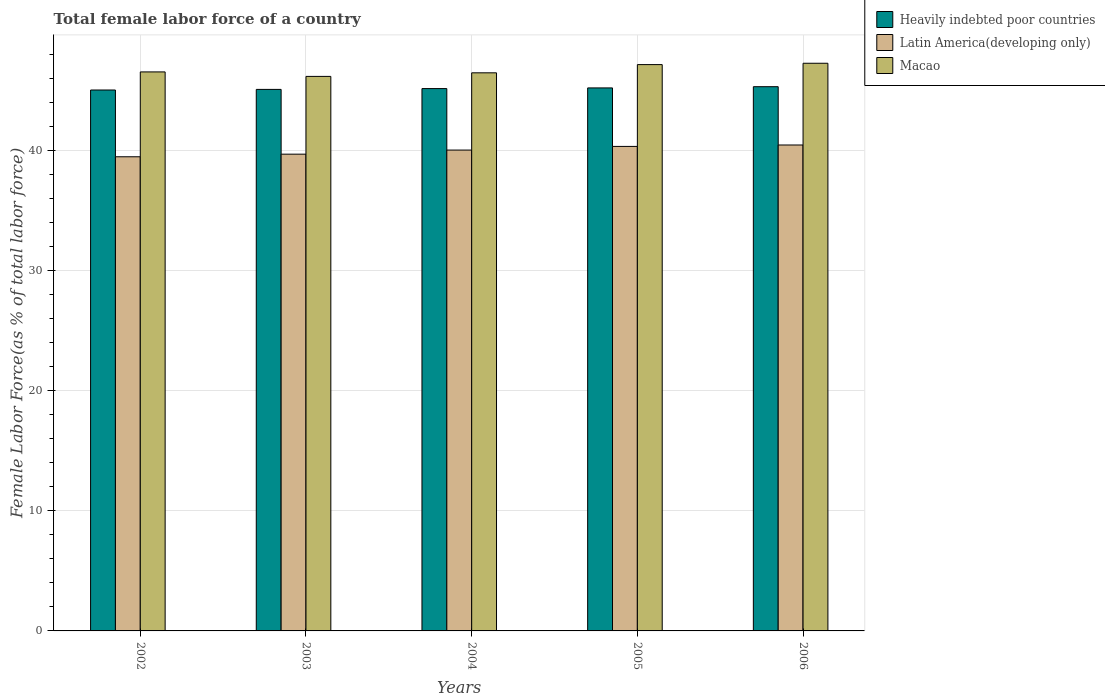How many groups of bars are there?
Give a very brief answer. 5. Are the number of bars per tick equal to the number of legend labels?
Make the answer very short. Yes. How many bars are there on the 1st tick from the right?
Keep it short and to the point. 3. What is the percentage of female labor force in Heavily indebted poor countries in 2004?
Your answer should be compact. 45.15. Across all years, what is the maximum percentage of female labor force in Latin America(developing only)?
Make the answer very short. 40.45. Across all years, what is the minimum percentage of female labor force in Latin America(developing only)?
Offer a terse response. 39.47. What is the total percentage of female labor force in Latin America(developing only) in the graph?
Your response must be concise. 199.96. What is the difference between the percentage of female labor force in Heavily indebted poor countries in 2004 and that in 2005?
Ensure brevity in your answer.  -0.06. What is the difference between the percentage of female labor force in Macao in 2003 and the percentage of female labor force in Heavily indebted poor countries in 2006?
Ensure brevity in your answer.  0.86. What is the average percentage of female labor force in Latin America(developing only) per year?
Make the answer very short. 39.99. In the year 2005, what is the difference between the percentage of female labor force in Macao and percentage of female labor force in Latin America(developing only)?
Ensure brevity in your answer.  6.81. What is the ratio of the percentage of female labor force in Heavily indebted poor countries in 2002 to that in 2005?
Your response must be concise. 1. Is the percentage of female labor force in Macao in 2003 less than that in 2005?
Make the answer very short. Yes. What is the difference between the highest and the second highest percentage of female labor force in Heavily indebted poor countries?
Provide a succinct answer. 0.1. What is the difference between the highest and the lowest percentage of female labor force in Latin America(developing only)?
Ensure brevity in your answer.  0.98. Is the sum of the percentage of female labor force in Macao in 2003 and 2006 greater than the maximum percentage of female labor force in Heavily indebted poor countries across all years?
Give a very brief answer. Yes. What does the 1st bar from the left in 2003 represents?
Offer a terse response. Heavily indebted poor countries. What does the 1st bar from the right in 2004 represents?
Your response must be concise. Macao. Is it the case that in every year, the sum of the percentage of female labor force in Macao and percentage of female labor force in Heavily indebted poor countries is greater than the percentage of female labor force in Latin America(developing only)?
Give a very brief answer. Yes. How many years are there in the graph?
Ensure brevity in your answer.  5. Are the values on the major ticks of Y-axis written in scientific E-notation?
Ensure brevity in your answer.  No. Does the graph contain any zero values?
Give a very brief answer. No. Does the graph contain grids?
Offer a terse response. Yes. How are the legend labels stacked?
Offer a terse response. Vertical. What is the title of the graph?
Ensure brevity in your answer.  Total female labor force of a country. Does "Sierra Leone" appear as one of the legend labels in the graph?
Give a very brief answer. No. What is the label or title of the Y-axis?
Offer a terse response. Female Labor Force(as % of total labor force). What is the Female Labor Force(as % of total labor force) in Heavily indebted poor countries in 2002?
Give a very brief answer. 45.03. What is the Female Labor Force(as % of total labor force) of Latin America(developing only) in 2002?
Offer a very short reply. 39.47. What is the Female Labor Force(as % of total labor force) of Macao in 2002?
Your answer should be compact. 46.53. What is the Female Labor Force(as % of total labor force) in Heavily indebted poor countries in 2003?
Provide a short and direct response. 45.08. What is the Female Labor Force(as % of total labor force) of Latin America(developing only) in 2003?
Offer a very short reply. 39.69. What is the Female Labor Force(as % of total labor force) in Macao in 2003?
Your response must be concise. 46.16. What is the Female Labor Force(as % of total labor force) of Heavily indebted poor countries in 2004?
Keep it short and to the point. 45.15. What is the Female Labor Force(as % of total labor force) of Latin America(developing only) in 2004?
Provide a short and direct response. 40.03. What is the Female Labor Force(as % of total labor force) of Macao in 2004?
Offer a very short reply. 46.46. What is the Female Labor Force(as % of total labor force) in Heavily indebted poor countries in 2005?
Provide a succinct answer. 45.2. What is the Female Labor Force(as % of total labor force) of Latin America(developing only) in 2005?
Your response must be concise. 40.33. What is the Female Labor Force(as % of total labor force) in Macao in 2005?
Ensure brevity in your answer.  47.14. What is the Female Labor Force(as % of total labor force) of Heavily indebted poor countries in 2006?
Your answer should be compact. 45.3. What is the Female Labor Force(as % of total labor force) in Latin America(developing only) in 2006?
Ensure brevity in your answer.  40.45. What is the Female Labor Force(as % of total labor force) in Macao in 2006?
Provide a succinct answer. 47.25. Across all years, what is the maximum Female Labor Force(as % of total labor force) in Heavily indebted poor countries?
Your answer should be compact. 45.3. Across all years, what is the maximum Female Labor Force(as % of total labor force) in Latin America(developing only)?
Offer a terse response. 40.45. Across all years, what is the maximum Female Labor Force(as % of total labor force) of Macao?
Give a very brief answer. 47.25. Across all years, what is the minimum Female Labor Force(as % of total labor force) of Heavily indebted poor countries?
Provide a succinct answer. 45.03. Across all years, what is the minimum Female Labor Force(as % of total labor force) in Latin America(developing only)?
Ensure brevity in your answer.  39.47. Across all years, what is the minimum Female Labor Force(as % of total labor force) of Macao?
Offer a very short reply. 46.16. What is the total Female Labor Force(as % of total labor force) in Heavily indebted poor countries in the graph?
Make the answer very short. 225.75. What is the total Female Labor Force(as % of total labor force) in Latin America(developing only) in the graph?
Make the answer very short. 199.96. What is the total Female Labor Force(as % of total labor force) in Macao in the graph?
Provide a succinct answer. 233.54. What is the difference between the Female Labor Force(as % of total labor force) of Heavily indebted poor countries in 2002 and that in 2003?
Your answer should be very brief. -0.05. What is the difference between the Female Labor Force(as % of total labor force) of Latin America(developing only) in 2002 and that in 2003?
Provide a succinct answer. -0.22. What is the difference between the Female Labor Force(as % of total labor force) of Macao in 2002 and that in 2003?
Your answer should be very brief. 0.37. What is the difference between the Female Labor Force(as % of total labor force) of Heavily indebted poor countries in 2002 and that in 2004?
Keep it short and to the point. -0.12. What is the difference between the Female Labor Force(as % of total labor force) in Latin America(developing only) in 2002 and that in 2004?
Ensure brevity in your answer.  -0.56. What is the difference between the Female Labor Force(as % of total labor force) of Macao in 2002 and that in 2004?
Your answer should be compact. 0.08. What is the difference between the Female Labor Force(as % of total labor force) in Heavily indebted poor countries in 2002 and that in 2005?
Your answer should be very brief. -0.17. What is the difference between the Female Labor Force(as % of total labor force) of Latin America(developing only) in 2002 and that in 2005?
Make the answer very short. -0.86. What is the difference between the Female Labor Force(as % of total labor force) of Macao in 2002 and that in 2005?
Your response must be concise. -0.61. What is the difference between the Female Labor Force(as % of total labor force) in Heavily indebted poor countries in 2002 and that in 2006?
Your answer should be compact. -0.28. What is the difference between the Female Labor Force(as % of total labor force) in Latin America(developing only) in 2002 and that in 2006?
Your answer should be very brief. -0.98. What is the difference between the Female Labor Force(as % of total labor force) of Macao in 2002 and that in 2006?
Your response must be concise. -0.72. What is the difference between the Female Labor Force(as % of total labor force) in Heavily indebted poor countries in 2003 and that in 2004?
Give a very brief answer. -0.07. What is the difference between the Female Labor Force(as % of total labor force) in Latin America(developing only) in 2003 and that in 2004?
Your answer should be very brief. -0.34. What is the difference between the Female Labor Force(as % of total labor force) in Macao in 2003 and that in 2004?
Offer a terse response. -0.3. What is the difference between the Female Labor Force(as % of total labor force) in Heavily indebted poor countries in 2003 and that in 2005?
Your response must be concise. -0.12. What is the difference between the Female Labor Force(as % of total labor force) in Latin America(developing only) in 2003 and that in 2005?
Ensure brevity in your answer.  -0.65. What is the difference between the Female Labor Force(as % of total labor force) in Macao in 2003 and that in 2005?
Your answer should be compact. -0.98. What is the difference between the Female Labor Force(as % of total labor force) in Heavily indebted poor countries in 2003 and that in 2006?
Provide a short and direct response. -0.22. What is the difference between the Female Labor Force(as % of total labor force) of Latin America(developing only) in 2003 and that in 2006?
Your response must be concise. -0.76. What is the difference between the Female Labor Force(as % of total labor force) in Macao in 2003 and that in 2006?
Offer a terse response. -1.09. What is the difference between the Female Labor Force(as % of total labor force) in Heavily indebted poor countries in 2004 and that in 2005?
Make the answer very short. -0.06. What is the difference between the Female Labor Force(as % of total labor force) of Latin America(developing only) in 2004 and that in 2005?
Give a very brief answer. -0.3. What is the difference between the Female Labor Force(as % of total labor force) in Macao in 2004 and that in 2005?
Your response must be concise. -0.68. What is the difference between the Female Labor Force(as % of total labor force) in Heavily indebted poor countries in 2004 and that in 2006?
Offer a very short reply. -0.16. What is the difference between the Female Labor Force(as % of total labor force) of Latin America(developing only) in 2004 and that in 2006?
Offer a terse response. -0.42. What is the difference between the Female Labor Force(as % of total labor force) in Macao in 2004 and that in 2006?
Keep it short and to the point. -0.8. What is the difference between the Female Labor Force(as % of total labor force) of Heavily indebted poor countries in 2005 and that in 2006?
Make the answer very short. -0.1. What is the difference between the Female Labor Force(as % of total labor force) of Latin America(developing only) in 2005 and that in 2006?
Make the answer very short. -0.12. What is the difference between the Female Labor Force(as % of total labor force) of Macao in 2005 and that in 2006?
Make the answer very short. -0.11. What is the difference between the Female Labor Force(as % of total labor force) of Heavily indebted poor countries in 2002 and the Female Labor Force(as % of total labor force) of Latin America(developing only) in 2003?
Your answer should be compact. 5.34. What is the difference between the Female Labor Force(as % of total labor force) in Heavily indebted poor countries in 2002 and the Female Labor Force(as % of total labor force) in Macao in 2003?
Your answer should be very brief. -1.13. What is the difference between the Female Labor Force(as % of total labor force) of Latin America(developing only) in 2002 and the Female Labor Force(as % of total labor force) of Macao in 2003?
Your answer should be very brief. -6.69. What is the difference between the Female Labor Force(as % of total labor force) of Heavily indebted poor countries in 2002 and the Female Labor Force(as % of total labor force) of Latin America(developing only) in 2004?
Give a very brief answer. 5. What is the difference between the Female Labor Force(as % of total labor force) in Heavily indebted poor countries in 2002 and the Female Labor Force(as % of total labor force) in Macao in 2004?
Offer a terse response. -1.43. What is the difference between the Female Labor Force(as % of total labor force) of Latin America(developing only) in 2002 and the Female Labor Force(as % of total labor force) of Macao in 2004?
Keep it short and to the point. -6.99. What is the difference between the Female Labor Force(as % of total labor force) of Heavily indebted poor countries in 2002 and the Female Labor Force(as % of total labor force) of Latin America(developing only) in 2005?
Keep it short and to the point. 4.7. What is the difference between the Female Labor Force(as % of total labor force) of Heavily indebted poor countries in 2002 and the Female Labor Force(as % of total labor force) of Macao in 2005?
Your answer should be compact. -2.12. What is the difference between the Female Labor Force(as % of total labor force) of Latin America(developing only) in 2002 and the Female Labor Force(as % of total labor force) of Macao in 2005?
Offer a very short reply. -7.67. What is the difference between the Female Labor Force(as % of total labor force) in Heavily indebted poor countries in 2002 and the Female Labor Force(as % of total labor force) in Latin America(developing only) in 2006?
Offer a very short reply. 4.58. What is the difference between the Female Labor Force(as % of total labor force) in Heavily indebted poor countries in 2002 and the Female Labor Force(as % of total labor force) in Macao in 2006?
Provide a short and direct response. -2.23. What is the difference between the Female Labor Force(as % of total labor force) of Latin America(developing only) in 2002 and the Female Labor Force(as % of total labor force) of Macao in 2006?
Your answer should be very brief. -7.78. What is the difference between the Female Labor Force(as % of total labor force) of Heavily indebted poor countries in 2003 and the Female Labor Force(as % of total labor force) of Latin America(developing only) in 2004?
Your answer should be compact. 5.05. What is the difference between the Female Labor Force(as % of total labor force) in Heavily indebted poor countries in 2003 and the Female Labor Force(as % of total labor force) in Macao in 2004?
Your answer should be very brief. -1.38. What is the difference between the Female Labor Force(as % of total labor force) of Latin America(developing only) in 2003 and the Female Labor Force(as % of total labor force) of Macao in 2004?
Provide a short and direct response. -6.77. What is the difference between the Female Labor Force(as % of total labor force) of Heavily indebted poor countries in 2003 and the Female Labor Force(as % of total labor force) of Latin America(developing only) in 2005?
Offer a very short reply. 4.75. What is the difference between the Female Labor Force(as % of total labor force) of Heavily indebted poor countries in 2003 and the Female Labor Force(as % of total labor force) of Macao in 2005?
Offer a very short reply. -2.06. What is the difference between the Female Labor Force(as % of total labor force) of Latin America(developing only) in 2003 and the Female Labor Force(as % of total labor force) of Macao in 2005?
Your answer should be very brief. -7.46. What is the difference between the Female Labor Force(as % of total labor force) in Heavily indebted poor countries in 2003 and the Female Labor Force(as % of total labor force) in Latin America(developing only) in 2006?
Your answer should be very brief. 4.63. What is the difference between the Female Labor Force(as % of total labor force) in Heavily indebted poor countries in 2003 and the Female Labor Force(as % of total labor force) in Macao in 2006?
Give a very brief answer. -2.18. What is the difference between the Female Labor Force(as % of total labor force) in Latin America(developing only) in 2003 and the Female Labor Force(as % of total labor force) in Macao in 2006?
Provide a succinct answer. -7.57. What is the difference between the Female Labor Force(as % of total labor force) in Heavily indebted poor countries in 2004 and the Female Labor Force(as % of total labor force) in Latin America(developing only) in 2005?
Give a very brief answer. 4.81. What is the difference between the Female Labor Force(as % of total labor force) of Heavily indebted poor countries in 2004 and the Female Labor Force(as % of total labor force) of Macao in 2005?
Your answer should be very brief. -2. What is the difference between the Female Labor Force(as % of total labor force) of Latin America(developing only) in 2004 and the Female Labor Force(as % of total labor force) of Macao in 2005?
Make the answer very short. -7.11. What is the difference between the Female Labor Force(as % of total labor force) in Heavily indebted poor countries in 2004 and the Female Labor Force(as % of total labor force) in Latin America(developing only) in 2006?
Your response must be concise. 4.7. What is the difference between the Female Labor Force(as % of total labor force) in Heavily indebted poor countries in 2004 and the Female Labor Force(as % of total labor force) in Macao in 2006?
Offer a very short reply. -2.11. What is the difference between the Female Labor Force(as % of total labor force) of Latin America(developing only) in 2004 and the Female Labor Force(as % of total labor force) of Macao in 2006?
Your answer should be very brief. -7.23. What is the difference between the Female Labor Force(as % of total labor force) in Heavily indebted poor countries in 2005 and the Female Labor Force(as % of total labor force) in Latin America(developing only) in 2006?
Provide a succinct answer. 4.75. What is the difference between the Female Labor Force(as % of total labor force) in Heavily indebted poor countries in 2005 and the Female Labor Force(as % of total labor force) in Macao in 2006?
Your answer should be very brief. -2.05. What is the difference between the Female Labor Force(as % of total labor force) in Latin America(developing only) in 2005 and the Female Labor Force(as % of total labor force) in Macao in 2006?
Provide a succinct answer. -6.92. What is the average Female Labor Force(as % of total labor force) in Heavily indebted poor countries per year?
Provide a succinct answer. 45.15. What is the average Female Labor Force(as % of total labor force) in Latin America(developing only) per year?
Your answer should be very brief. 39.99. What is the average Female Labor Force(as % of total labor force) of Macao per year?
Your answer should be compact. 46.71. In the year 2002, what is the difference between the Female Labor Force(as % of total labor force) in Heavily indebted poor countries and Female Labor Force(as % of total labor force) in Latin America(developing only)?
Ensure brevity in your answer.  5.56. In the year 2002, what is the difference between the Female Labor Force(as % of total labor force) of Heavily indebted poor countries and Female Labor Force(as % of total labor force) of Macao?
Keep it short and to the point. -1.51. In the year 2002, what is the difference between the Female Labor Force(as % of total labor force) of Latin America(developing only) and Female Labor Force(as % of total labor force) of Macao?
Your answer should be compact. -7.06. In the year 2003, what is the difference between the Female Labor Force(as % of total labor force) in Heavily indebted poor countries and Female Labor Force(as % of total labor force) in Latin America(developing only)?
Offer a very short reply. 5.39. In the year 2003, what is the difference between the Female Labor Force(as % of total labor force) in Heavily indebted poor countries and Female Labor Force(as % of total labor force) in Macao?
Ensure brevity in your answer.  -1.08. In the year 2003, what is the difference between the Female Labor Force(as % of total labor force) in Latin America(developing only) and Female Labor Force(as % of total labor force) in Macao?
Offer a terse response. -6.47. In the year 2004, what is the difference between the Female Labor Force(as % of total labor force) in Heavily indebted poor countries and Female Labor Force(as % of total labor force) in Latin America(developing only)?
Make the answer very short. 5.12. In the year 2004, what is the difference between the Female Labor Force(as % of total labor force) of Heavily indebted poor countries and Female Labor Force(as % of total labor force) of Macao?
Offer a terse response. -1.31. In the year 2004, what is the difference between the Female Labor Force(as % of total labor force) in Latin America(developing only) and Female Labor Force(as % of total labor force) in Macao?
Keep it short and to the point. -6.43. In the year 2005, what is the difference between the Female Labor Force(as % of total labor force) of Heavily indebted poor countries and Female Labor Force(as % of total labor force) of Latin America(developing only)?
Provide a short and direct response. 4.87. In the year 2005, what is the difference between the Female Labor Force(as % of total labor force) in Heavily indebted poor countries and Female Labor Force(as % of total labor force) in Macao?
Give a very brief answer. -1.94. In the year 2005, what is the difference between the Female Labor Force(as % of total labor force) of Latin America(developing only) and Female Labor Force(as % of total labor force) of Macao?
Provide a short and direct response. -6.81. In the year 2006, what is the difference between the Female Labor Force(as % of total labor force) in Heavily indebted poor countries and Female Labor Force(as % of total labor force) in Latin America(developing only)?
Give a very brief answer. 4.85. In the year 2006, what is the difference between the Female Labor Force(as % of total labor force) of Heavily indebted poor countries and Female Labor Force(as % of total labor force) of Macao?
Offer a terse response. -1.95. In the year 2006, what is the difference between the Female Labor Force(as % of total labor force) of Latin America(developing only) and Female Labor Force(as % of total labor force) of Macao?
Make the answer very short. -6.8. What is the ratio of the Female Labor Force(as % of total labor force) of Heavily indebted poor countries in 2002 to that in 2003?
Provide a succinct answer. 1. What is the ratio of the Female Labor Force(as % of total labor force) of Latin America(developing only) in 2002 to that in 2003?
Keep it short and to the point. 0.99. What is the ratio of the Female Labor Force(as % of total labor force) in Heavily indebted poor countries in 2002 to that in 2004?
Keep it short and to the point. 1. What is the ratio of the Female Labor Force(as % of total labor force) in Latin America(developing only) in 2002 to that in 2004?
Provide a short and direct response. 0.99. What is the ratio of the Female Labor Force(as % of total labor force) in Macao in 2002 to that in 2004?
Your answer should be very brief. 1. What is the ratio of the Female Labor Force(as % of total labor force) of Latin America(developing only) in 2002 to that in 2005?
Make the answer very short. 0.98. What is the ratio of the Female Labor Force(as % of total labor force) of Macao in 2002 to that in 2005?
Provide a succinct answer. 0.99. What is the ratio of the Female Labor Force(as % of total labor force) of Heavily indebted poor countries in 2002 to that in 2006?
Give a very brief answer. 0.99. What is the ratio of the Female Labor Force(as % of total labor force) of Latin America(developing only) in 2002 to that in 2006?
Your answer should be very brief. 0.98. What is the ratio of the Female Labor Force(as % of total labor force) in Macao in 2002 to that in 2006?
Provide a short and direct response. 0.98. What is the ratio of the Female Labor Force(as % of total labor force) of Latin America(developing only) in 2003 to that in 2005?
Provide a succinct answer. 0.98. What is the ratio of the Female Labor Force(as % of total labor force) of Macao in 2003 to that in 2005?
Keep it short and to the point. 0.98. What is the ratio of the Female Labor Force(as % of total labor force) in Heavily indebted poor countries in 2003 to that in 2006?
Provide a succinct answer. 0.99. What is the ratio of the Female Labor Force(as % of total labor force) in Latin America(developing only) in 2003 to that in 2006?
Provide a succinct answer. 0.98. What is the ratio of the Female Labor Force(as % of total labor force) in Macao in 2003 to that in 2006?
Keep it short and to the point. 0.98. What is the ratio of the Female Labor Force(as % of total labor force) in Heavily indebted poor countries in 2004 to that in 2005?
Ensure brevity in your answer.  1. What is the ratio of the Female Labor Force(as % of total labor force) in Latin America(developing only) in 2004 to that in 2005?
Your response must be concise. 0.99. What is the ratio of the Female Labor Force(as % of total labor force) of Macao in 2004 to that in 2005?
Ensure brevity in your answer.  0.99. What is the ratio of the Female Labor Force(as % of total labor force) in Heavily indebted poor countries in 2004 to that in 2006?
Offer a terse response. 1. What is the ratio of the Female Labor Force(as % of total labor force) of Macao in 2004 to that in 2006?
Provide a succinct answer. 0.98. What is the ratio of the Female Labor Force(as % of total labor force) in Heavily indebted poor countries in 2005 to that in 2006?
Keep it short and to the point. 1. What is the ratio of the Female Labor Force(as % of total labor force) of Latin America(developing only) in 2005 to that in 2006?
Your response must be concise. 1. What is the ratio of the Female Labor Force(as % of total labor force) in Macao in 2005 to that in 2006?
Offer a terse response. 1. What is the difference between the highest and the second highest Female Labor Force(as % of total labor force) of Heavily indebted poor countries?
Offer a very short reply. 0.1. What is the difference between the highest and the second highest Female Labor Force(as % of total labor force) of Latin America(developing only)?
Your answer should be very brief. 0.12. What is the difference between the highest and the second highest Female Labor Force(as % of total labor force) of Macao?
Ensure brevity in your answer.  0.11. What is the difference between the highest and the lowest Female Labor Force(as % of total labor force) in Heavily indebted poor countries?
Make the answer very short. 0.28. What is the difference between the highest and the lowest Female Labor Force(as % of total labor force) of Latin America(developing only)?
Make the answer very short. 0.98. What is the difference between the highest and the lowest Female Labor Force(as % of total labor force) of Macao?
Offer a terse response. 1.09. 